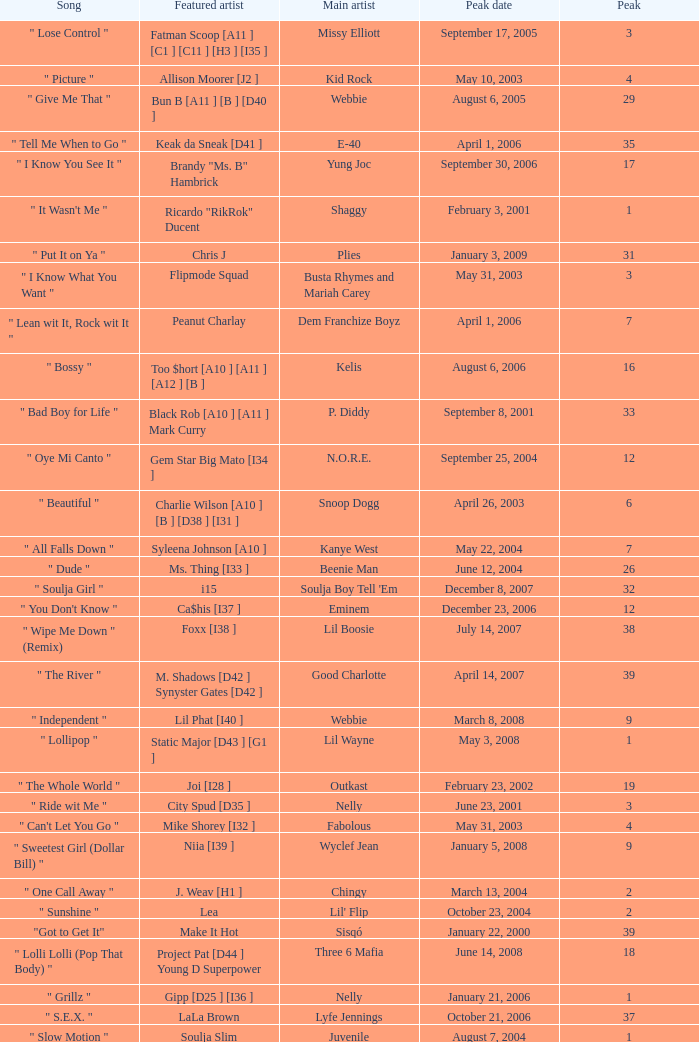What was the peak date of Kelis's song? August 6, 2006. 